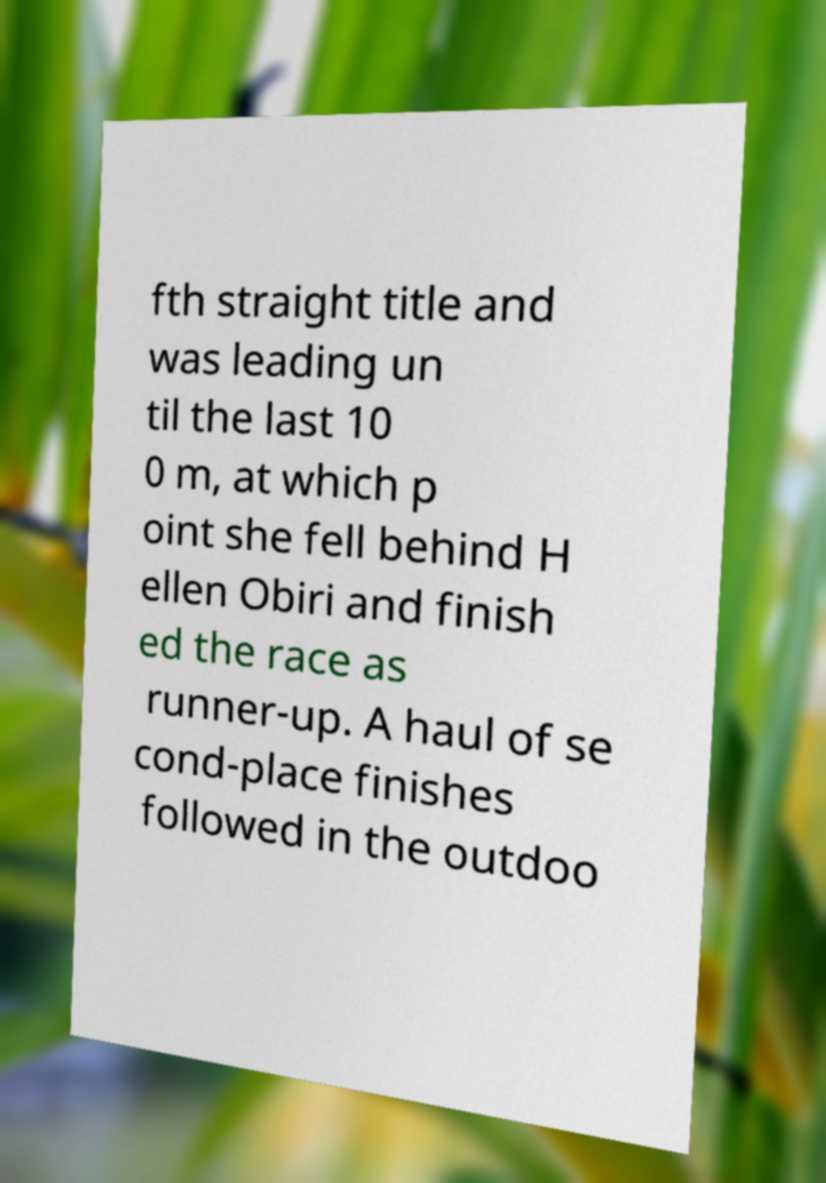I need the written content from this picture converted into text. Can you do that? fth straight title and was leading un til the last 10 0 m, at which p oint she fell behind H ellen Obiri and finish ed the race as runner-up. A haul of se cond-place finishes followed in the outdoo 